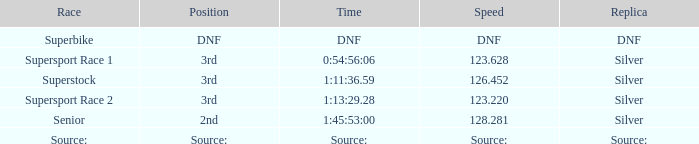Which race possesses a 3rd position and a rate of 12 Supersport Race 1. 